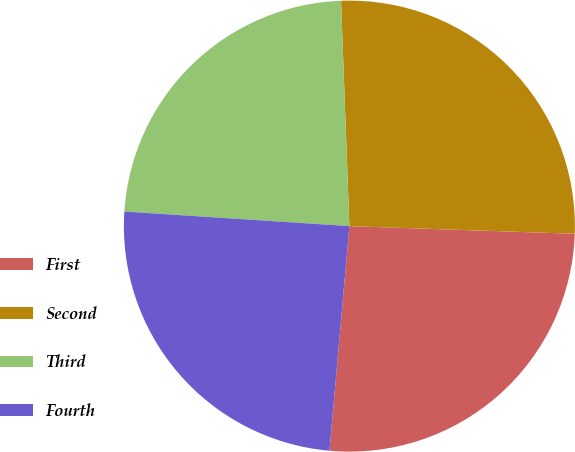Convert chart to OTSL. <chart><loc_0><loc_0><loc_500><loc_500><pie_chart><fcel>First<fcel>Second<fcel>Third<fcel>Fourth<nl><fcel>25.87%<fcel>26.13%<fcel>23.38%<fcel>24.62%<nl></chart> 